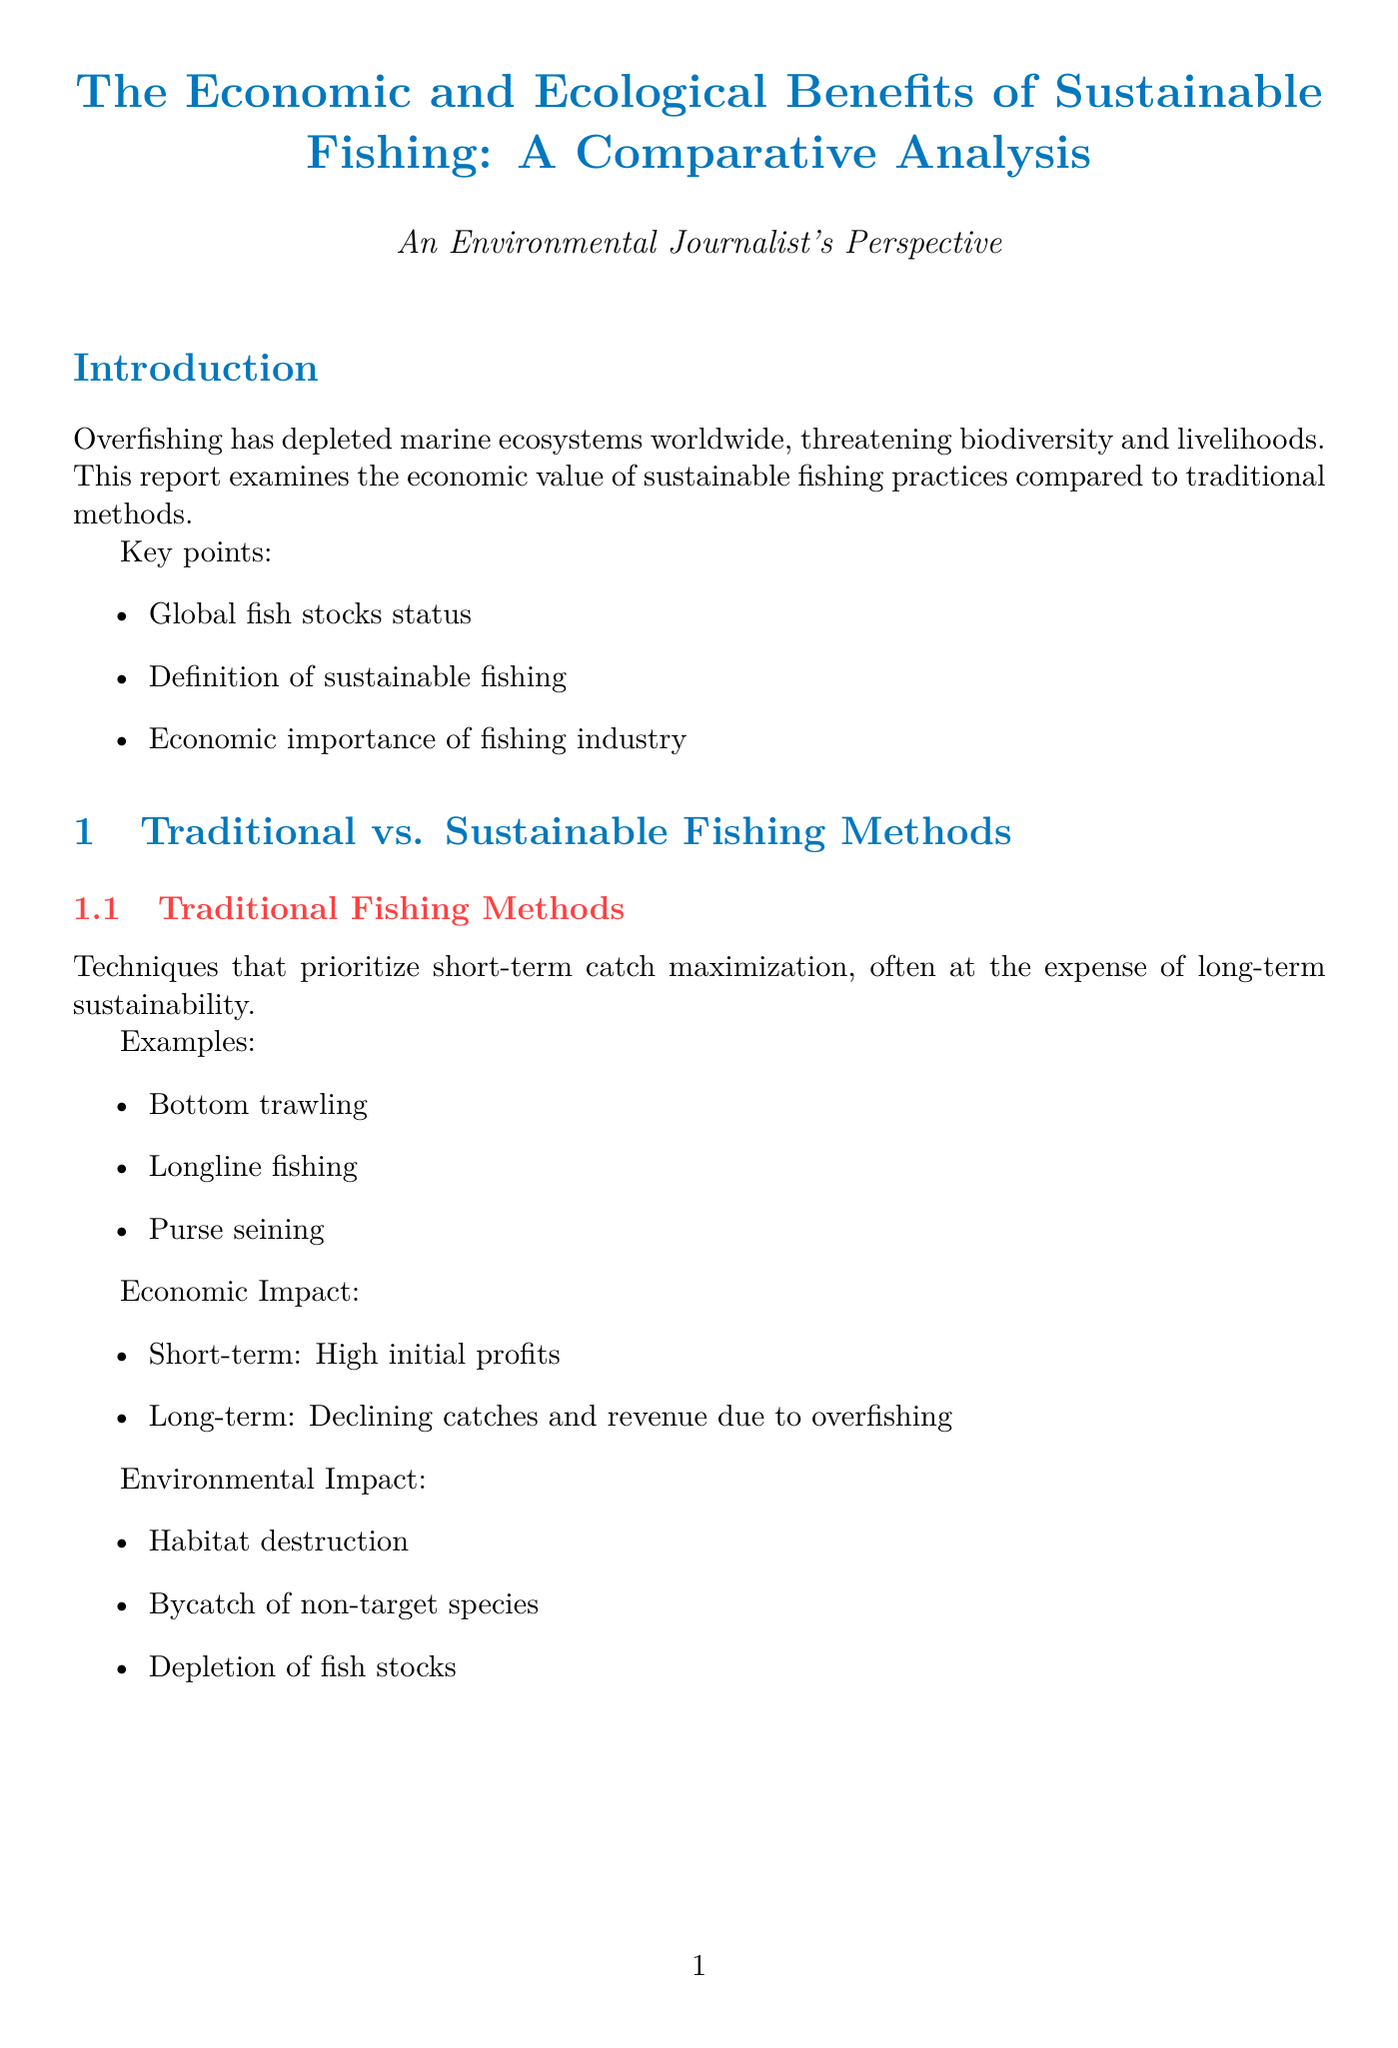what is the title of the report? The title is prominently displayed at the beginning of the document.
Answer: The Economic and Ecological Benefits of Sustainable Fishing: A Comparative Analysis what fishing method resulted in a consistent annual catch of 200 million fish? This information is found in the case studies section.
Answer: Sustainable what is the economic outcome of the Alaska Salmon Fishery? The economic outcome is explicitly stated in the case study details.
Answer: Consistent annual catch of 200 million fish, valued at $500 million how many million jobs does traditional fishing create? This figure is presented in the comparative analysis section.
Answer: Z million jobs what is the ecological outcome of the North Sea Cod Fishery? This outcome is detailed in the case studies section.
Answer: Severe depletion of cod stocks, now gradually recovering what is the impact of sustainable fishing on biodiversity? The effect is compared to traditional practices within the document.
Answer: Low negative impact which certification program is mentioned for sustainable seafood? These programs are listed under market trends.
Answer: Marine Stewardship Council (MSC) what is the short-term economic impact of sustainable fishing methods? This information is covered in the sustainable fishing methods section.
Answer: Lower initial profits what percentage more are consumers willing to pay for certified sustainable seafood? This statistic is included in the market trends section.
Answer: 10-15% more 